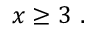Convert formula to latex. <formula><loc_0><loc_0><loc_500><loc_500>x \geq 3 .</formula> 